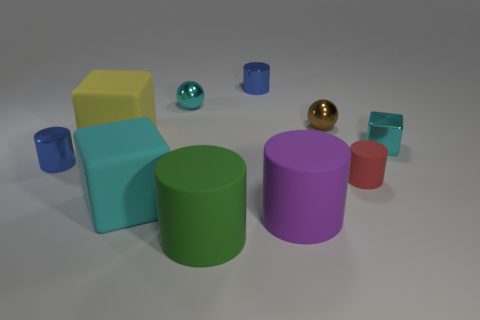There is a large thing that is the same color as the shiny block; what material is it?
Keep it short and to the point. Rubber. How many tiny metallic balls are the same color as the small metallic block?
Ensure brevity in your answer.  1. There is a tiny cyan thing left of the small red object; is its shape the same as the small brown thing?
Provide a short and direct response. Yes. Are there fewer shiny objects that are to the right of the small cyan shiny sphere than things that are behind the small cyan metal block?
Make the answer very short. Yes. There is a cube in front of the tiny red thing; what is its material?
Give a very brief answer. Rubber. What is the size of the metallic object that is the same color as the small metallic cube?
Give a very brief answer. Small. Are there any other yellow cubes of the same size as the shiny cube?
Make the answer very short. No. Does the small matte object have the same shape as the rubber object behind the small red matte object?
Your response must be concise. No. Is the size of the shiny cylinder behind the cyan sphere the same as the blue object to the left of the big cyan thing?
Offer a very short reply. Yes. What number of other objects are there of the same shape as the large green object?
Provide a succinct answer. 4. 